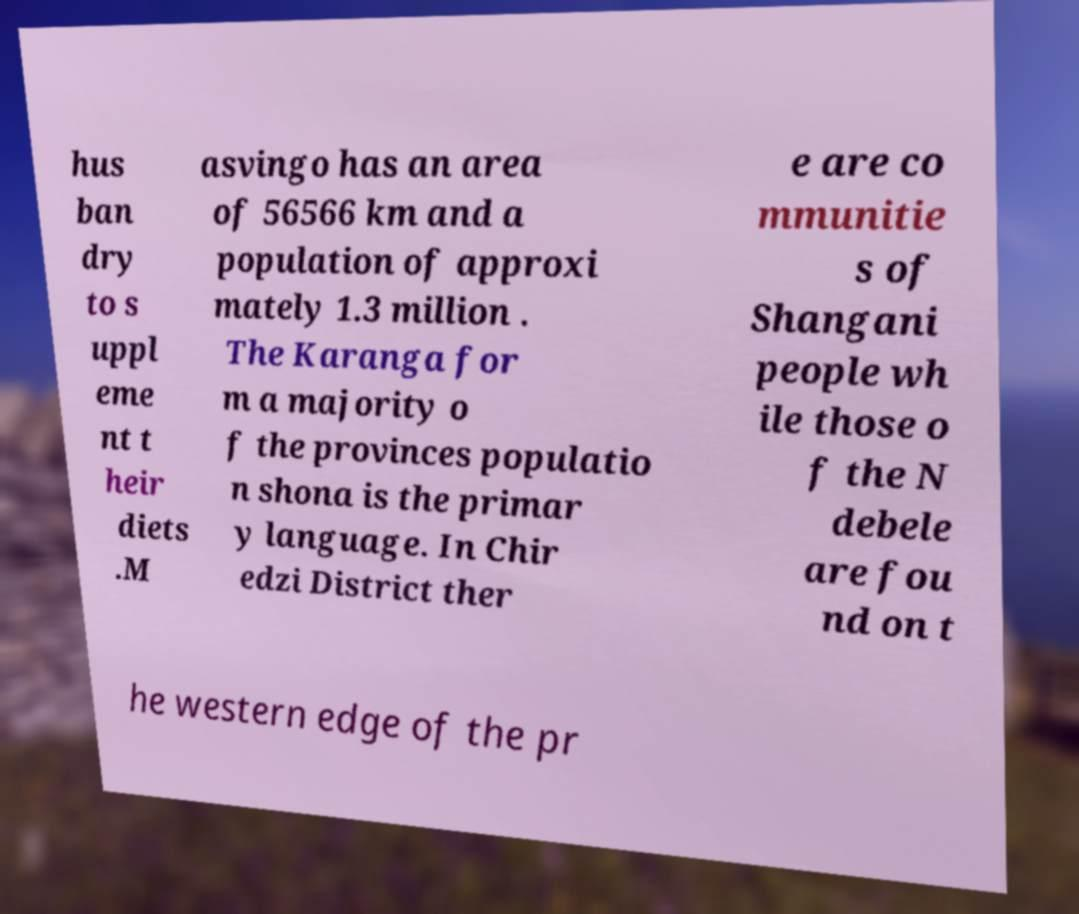For documentation purposes, I need the text within this image transcribed. Could you provide that? hus ban dry to s uppl eme nt t heir diets .M asvingo has an area of 56566 km and a population of approxi mately 1.3 million . The Karanga for m a majority o f the provinces populatio n shona is the primar y language. In Chir edzi District ther e are co mmunitie s of Shangani people wh ile those o f the N debele are fou nd on t he western edge of the pr 